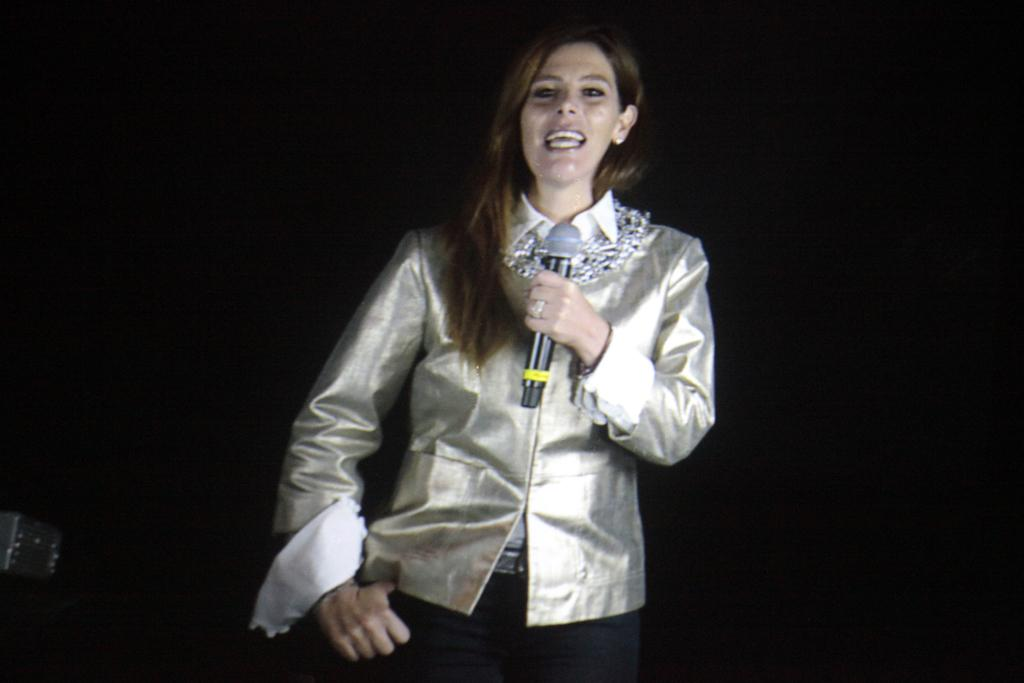Who is the main subject in the image? There is a woman in the image. What is the woman doing in the image? The woman is standing and holding a mic. What can be observed about the background of the image? The background of the image is dark. How many sheep are present in the image? There are no sheep present in the image. What ideas does the woman have in the image? The image does not provide information about the woman's ideas or thoughts. 